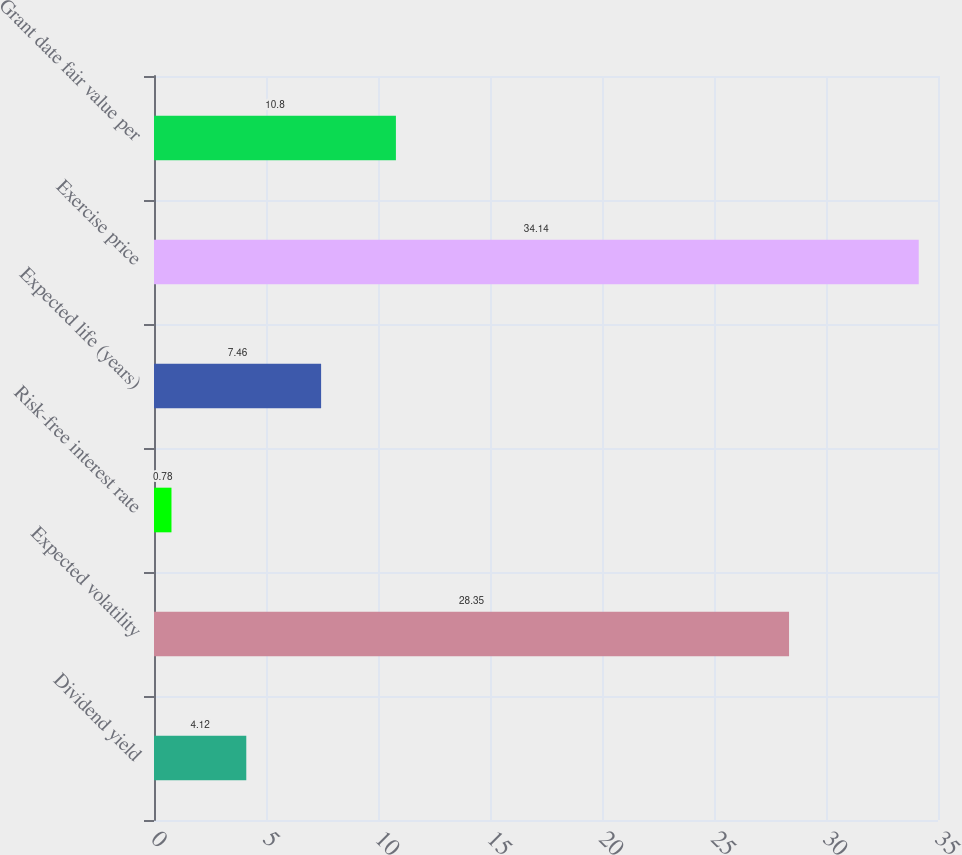<chart> <loc_0><loc_0><loc_500><loc_500><bar_chart><fcel>Dividend yield<fcel>Expected volatility<fcel>Risk-free interest rate<fcel>Expected life (years)<fcel>Exercise price<fcel>Grant date fair value per<nl><fcel>4.12<fcel>28.35<fcel>0.78<fcel>7.46<fcel>34.14<fcel>10.8<nl></chart> 